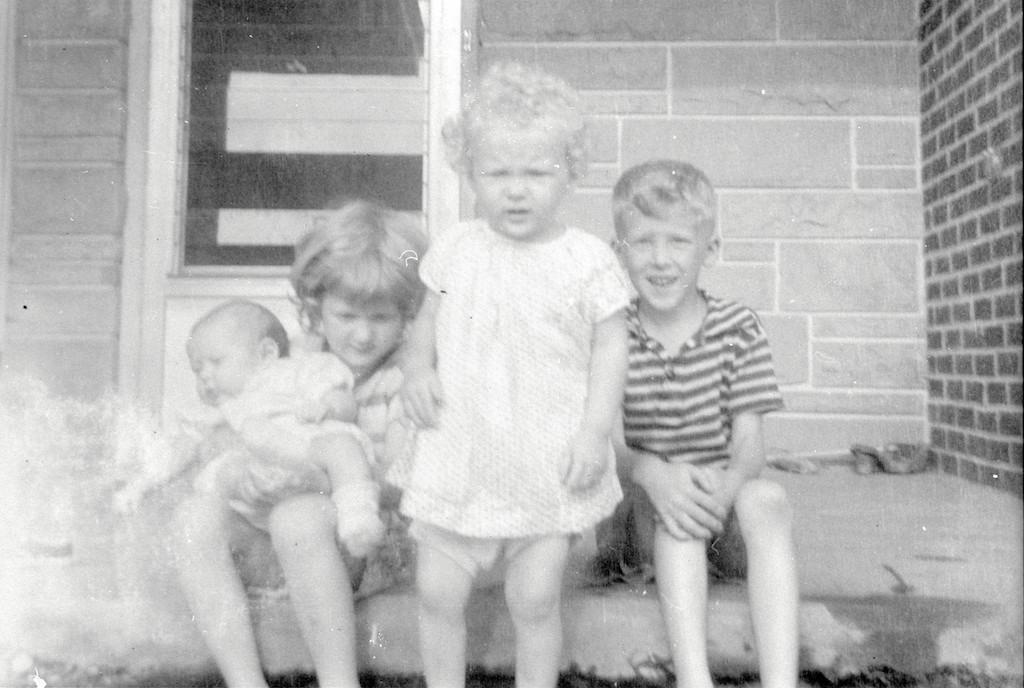Please provide a concise description of this image. In this image on the ground two kids are sitting. A kid is standing in the middle. A baby is in the lap of a kid sitting in the left. In the background there is a building. 